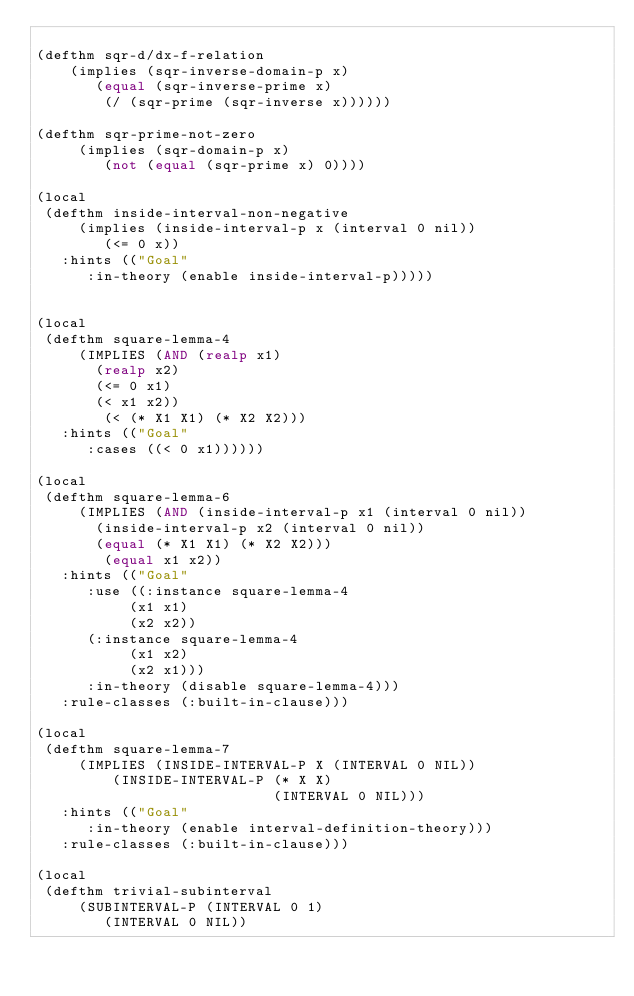Convert code to text. <code><loc_0><loc_0><loc_500><loc_500><_Lisp_>
(defthm sqr-d/dx-f-relation
    (implies (sqr-inverse-domain-p x)
	     (equal (sqr-inverse-prime x)
		    (/ (sqr-prime (sqr-inverse x))))))

(defthm sqr-prime-not-zero
     (implies (sqr-domain-p x)
	      (not (equal (sqr-prime x) 0))))

(local
 (defthm inside-interval-non-negative
     (implies (inside-interval-p x (interval 0 nil))
	      (<= 0 x))
   :hints (("Goal"
	    :in-theory (enable inside-interval-p)))))


(local
 (defthm square-lemma-4
     (IMPLIES (AND (realp x1)
		   (realp x2)
		   (<= 0 x1)
		   (< x1 x2))
	      (< (* X1 X1) (* X2 X2)))
   :hints (("Goal"
	    :cases ((< 0 x1))))))

(local
 (defthm square-lemma-6
     (IMPLIES (AND (inside-interval-p x1 (interval 0 nil))
		   (inside-interval-p x2 (interval 0 nil))
		   (equal (* X1 X1) (* X2 X2)))
	      (equal x1 x2))
   :hints (("Goal"
	    :use ((:instance square-lemma-4
			     (x1 x1)
			     (x2 x2))
		  (:instance square-lemma-4
			     (x1 x2)
			     (x2 x1)))
	    :in-theory (disable square-lemma-4)))
   :rule-classes (:built-in-clause)))

(local
 (defthm square-lemma-7
     (IMPLIES (INSIDE-INTERVAL-P X (INTERVAL 0 NIL))
         (INSIDE-INTERVAL-P (* X X)
                            (INTERVAL 0 NIL)))
   :hints (("Goal"
	    :in-theory (enable interval-definition-theory)))
   :rule-classes (:built-in-clause)))

(local
 (defthm trivial-subinterval
     (SUBINTERVAL-P (INTERVAL 0 1)
		    (INTERVAL 0 NIL))</code> 